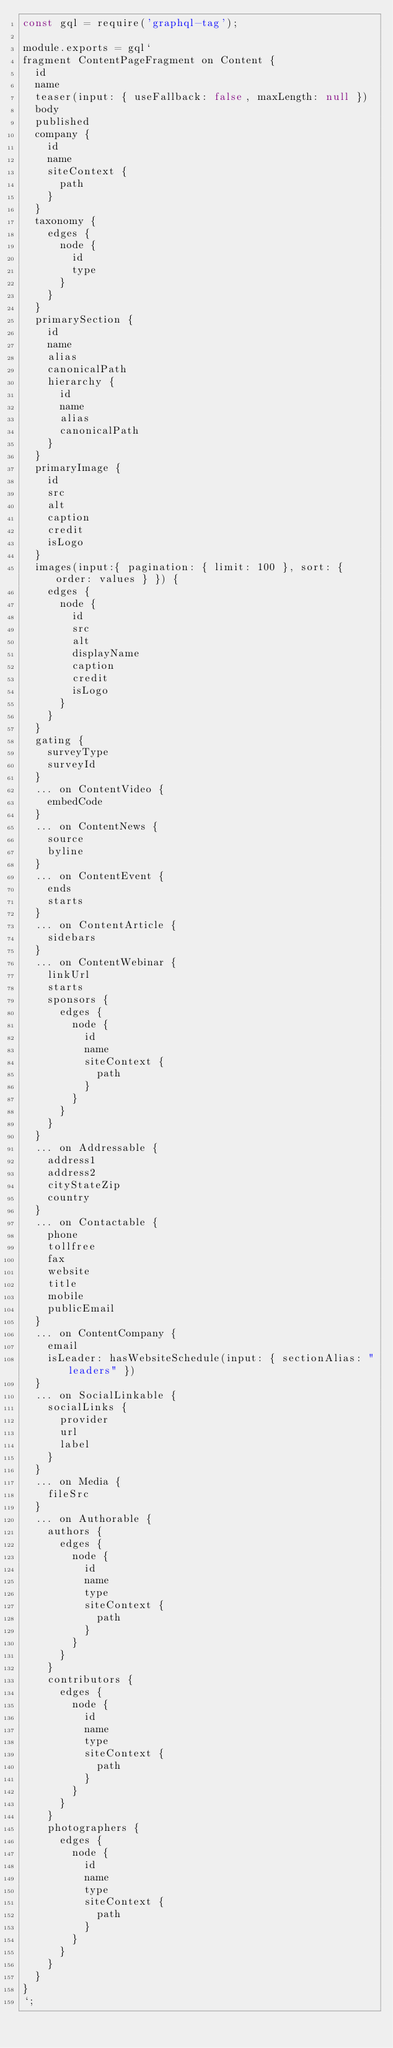Convert code to text. <code><loc_0><loc_0><loc_500><loc_500><_JavaScript_>const gql = require('graphql-tag');

module.exports = gql`
fragment ContentPageFragment on Content {
  id
  name
  teaser(input: { useFallback: false, maxLength: null })
  body
  published
  company {
    id
    name
    siteContext {
      path
    }
  }
  taxonomy {
    edges {
      node {
        id
        type
      }
    }
  }
  primarySection {
    id
    name
    alias
    canonicalPath
    hierarchy {
      id
      name
      alias
      canonicalPath
    }
  }
  primaryImage {
    id
    src
    alt
    caption
    credit
    isLogo
  }
  images(input:{ pagination: { limit: 100 }, sort: { order: values } }) {
    edges {
      node {
        id
        src
        alt
        displayName
        caption
        credit
        isLogo
      }
    }
  }
  gating {
    surveyType
    surveyId
  }
  ... on ContentVideo {
    embedCode
  }
  ... on ContentNews {
    source
    byline
  }
  ... on ContentEvent {
    ends
    starts
  }
  ... on ContentArticle {
    sidebars
  }
  ... on ContentWebinar {
    linkUrl
    starts
    sponsors {
      edges {
        node {
          id
          name
          siteContext {
            path
          }
        }
      }
    }
  }
  ... on Addressable {
    address1
    address2
    cityStateZip
    country
  }
  ... on Contactable {
    phone
    tollfree
    fax
    website
    title
    mobile
    publicEmail
  }
  ... on ContentCompany {
    email
    isLeader: hasWebsiteSchedule(input: { sectionAlias: "leaders" })
  }
  ... on SocialLinkable {
    socialLinks {
      provider
      url
      label
    }
  }
  ... on Media {
    fileSrc
  }
  ... on Authorable {
    authors {
      edges {
        node {
          id
          name
          type
          siteContext {
            path
          }
        }
      }
    }
    contributors {
      edges {
        node {
          id
          name
          type
          siteContext {
            path
          }
        }
      }
    }
    photographers {
      edges {
        node {
          id
          name
          type
          siteContext {
            path
          }
        }
      }
    }
  }
}
`;
</code> 